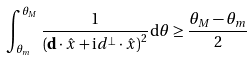<formula> <loc_0><loc_0><loc_500><loc_500>\int _ { \theta _ { m } } ^ { \theta _ { M } } \frac { 1 } { \left ( \mathbf d \cdot \hat { x } + \mathrm i d ^ { \perp } \cdot \hat { x } \right ) ^ { 2 } } \mathrm d \theta \geq \frac { \theta _ { M } - \theta _ { m } } { 2 }</formula> 